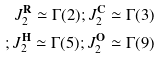Convert formula to latex. <formula><loc_0><loc_0><loc_500><loc_500>\\ J _ { 2 } ^ { \mathbf R } \simeq \Gamma ( 2 ) ; J _ { 2 } ^ { \mathbf C } \simeq \Gamma ( 3 ) \\ ; J _ { 2 } ^ { \mathbf H } \simeq \Gamma ( 5 ) ; J _ { 2 } ^ { \mathbf O } \simeq \Gamma ( 9 ) \\ \\</formula> 